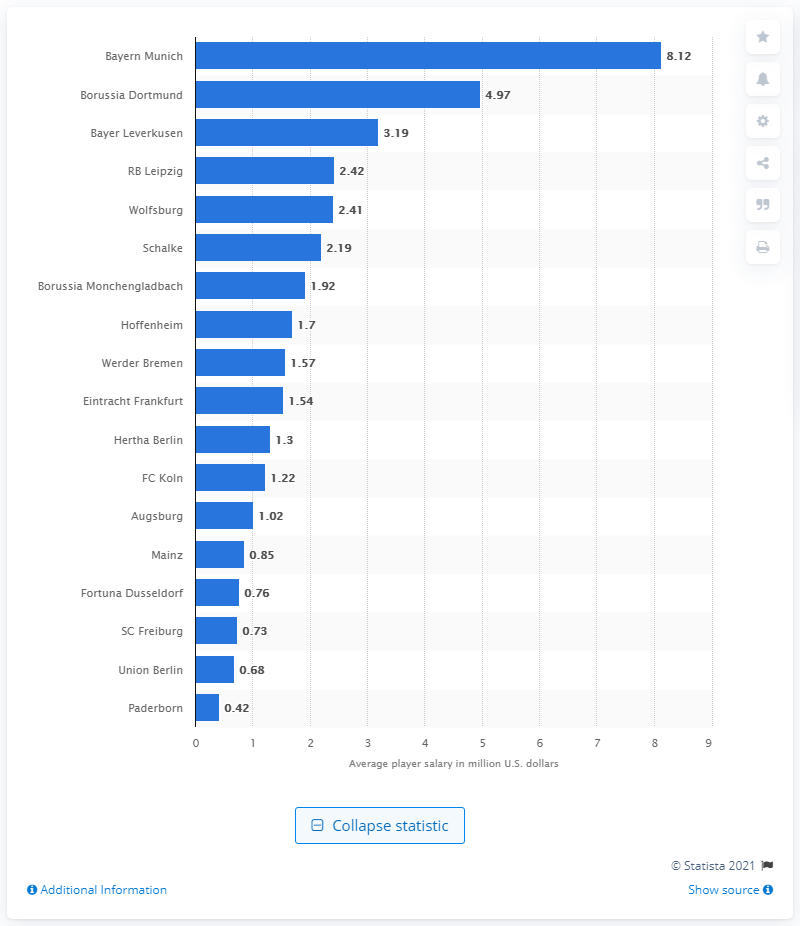Outline some significant characteristics in this image. Bayern Munich was the highest-paying club in the German Bundesliga during the 2019/2020 season. Bayern Munich's average annual player salary in the 2019/2020 season was 8.12. Paderborn is the lowest paying club in the Bundesliga, with a salary budget significantly lower than its competitors. 